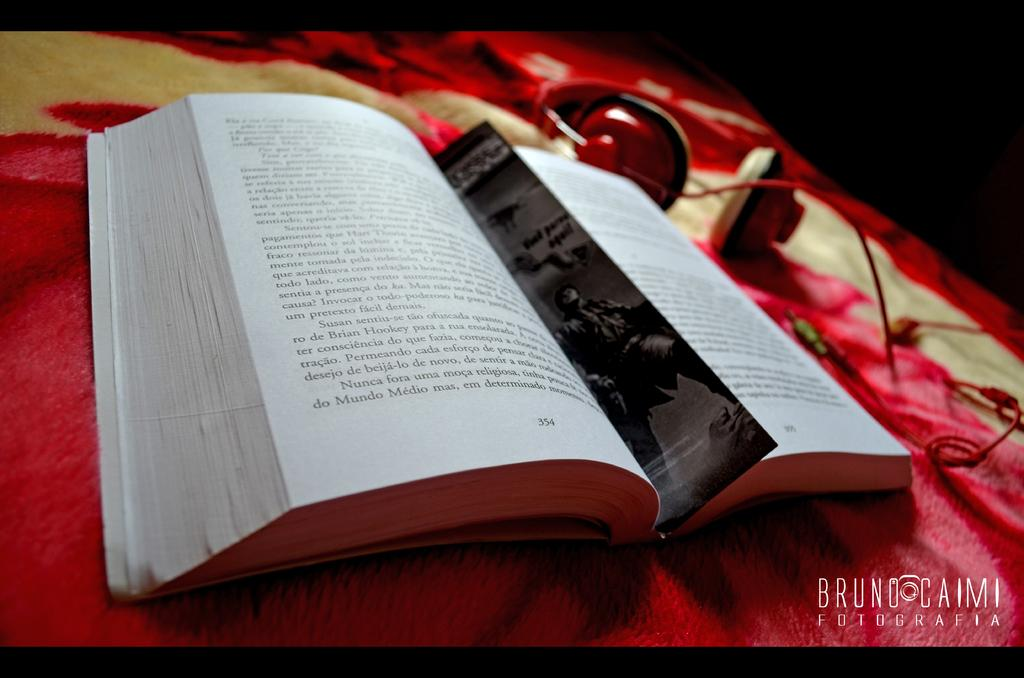<image>
Share a concise interpretation of the image provided. A bookmark is in a book open to page 354. 